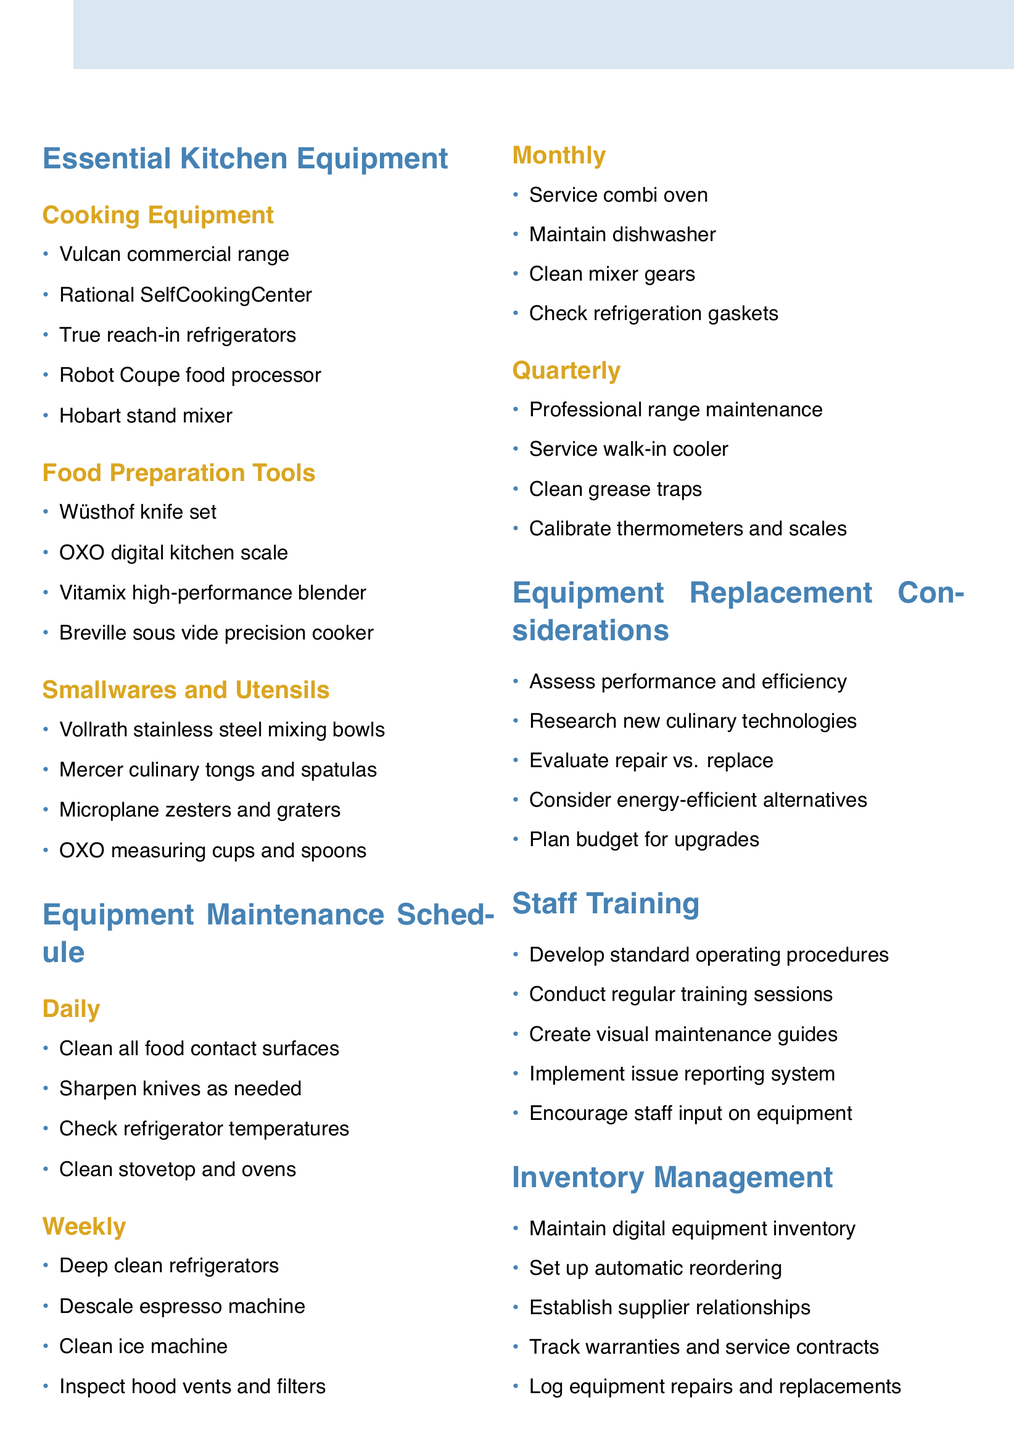What equipment is listed under Cooking Equipment? The Cooking Equipment section includes specific items listed for cooking in the kitchen, such as ranges and ovens.
Answer: Vulcan commercial range with 6 burners and griddle, Rational SelfCookingCenter combi oven, True reach-in refrigerators and freezers, Robot Coupe food processor, Hobart stand mixer What is the first task in the Daily Maintenance schedule? The Daily Maintenance section outlines tasks that need to be performed on a daily basis for the upkeep of equipment and kitchen hygiene.
Answer: Clean and sanitize all food contact surfaces How often is the espresso machine descaled? The maintenance schedule specifies tasks to be conducted on different frequency intervals.
Answer: Weekly What should be evaluated regarding equipment replacement? The section discusses considerations necessary for assessing whether to keep or replace kitchen equipment.
Answer: Repairing vs. replacing equipment What type of document is this? The document serves as an agenda that outlines both equipment inventory and maintenance schedules for a professional kitchen.
Answer: Culinary Equipment Inventory and Maintenance Schedule What is included in the Staff Training section? The section lists items aimed at training staff on the use and care of equipment, fostering a safe working environment.
Answer: Develop standard operating procedures for equipment use What is the frequency of professional maintenance for the Vulcan range? The maintenance schedule indicates when professional services should be employed for significant equipment upkeep.
Answer: Quarterly What is the purpose of maintaining a digital inventory? The document details practices for tracking kitchen equipment to facilitate management and ordering processes.
Answer: Maintain a digital inventory of all kitchen equipment 